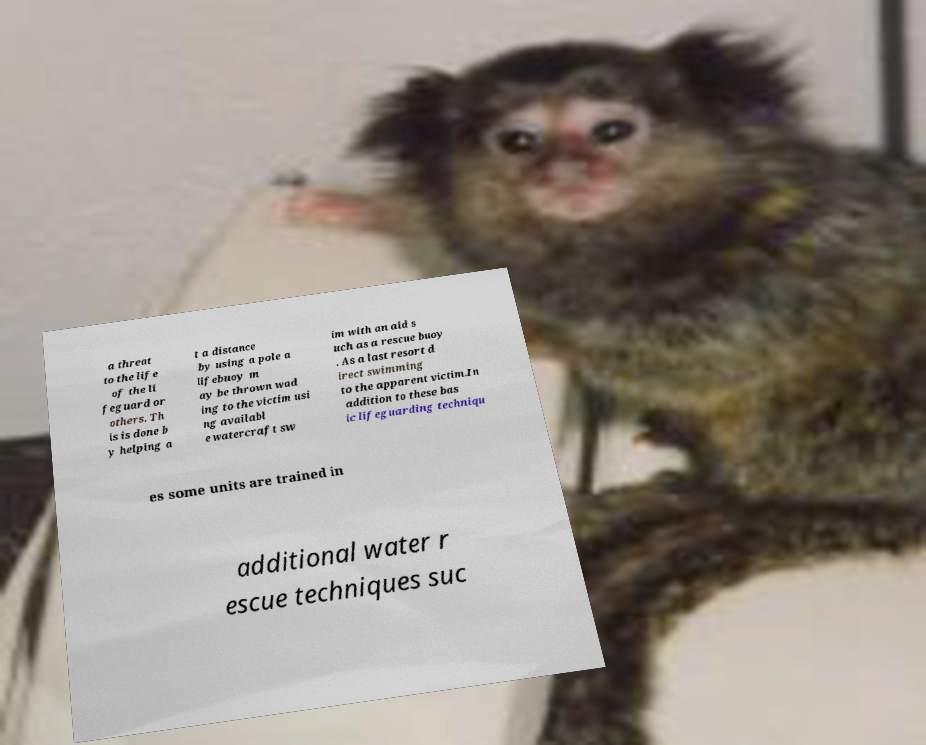I need the written content from this picture converted into text. Can you do that? a threat to the life of the li feguard or others. Th is is done b y helping a t a distance by using a pole a lifebuoy m ay be thrown wad ing to the victim usi ng availabl e watercraft sw im with an aid s uch as a rescue buoy . As a last resort d irect swimming to the apparent victim.In addition to these bas ic lifeguarding techniqu es some units are trained in additional water r escue techniques suc 